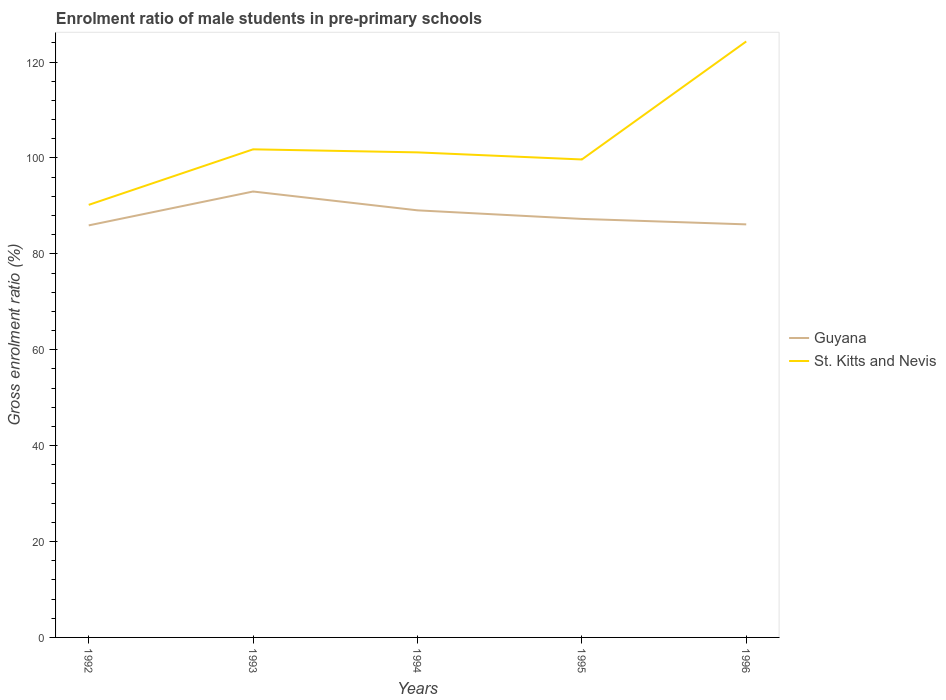Is the number of lines equal to the number of legend labels?
Your response must be concise. Yes. Across all years, what is the maximum enrolment ratio of male students in pre-primary schools in St. Kitts and Nevis?
Make the answer very short. 90.22. What is the total enrolment ratio of male students in pre-primary schools in St. Kitts and Nevis in the graph?
Your response must be concise. 0.64. What is the difference between the highest and the second highest enrolment ratio of male students in pre-primary schools in Guyana?
Your answer should be very brief. 7.06. Is the enrolment ratio of male students in pre-primary schools in St. Kitts and Nevis strictly greater than the enrolment ratio of male students in pre-primary schools in Guyana over the years?
Provide a succinct answer. No. How many lines are there?
Your answer should be very brief. 2. What is the difference between two consecutive major ticks on the Y-axis?
Keep it short and to the point. 20. Are the values on the major ticks of Y-axis written in scientific E-notation?
Provide a succinct answer. No. Does the graph contain grids?
Keep it short and to the point. No. Where does the legend appear in the graph?
Give a very brief answer. Center right. How many legend labels are there?
Your response must be concise. 2. How are the legend labels stacked?
Offer a terse response. Vertical. What is the title of the graph?
Offer a terse response. Enrolment ratio of male students in pre-primary schools. Does "St. Kitts and Nevis" appear as one of the legend labels in the graph?
Provide a short and direct response. Yes. What is the Gross enrolment ratio (%) of Guyana in 1992?
Your answer should be compact. 85.94. What is the Gross enrolment ratio (%) of St. Kitts and Nevis in 1992?
Make the answer very short. 90.22. What is the Gross enrolment ratio (%) in Guyana in 1993?
Offer a very short reply. 93. What is the Gross enrolment ratio (%) of St. Kitts and Nevis in 1993?
Keep it short and to the point. 101.8. What is the Gross enrolment ratio (%) of Guyana in 1994?
Give a very brief answer. 89.08. What is the Gross enrolment ratio (%) of St. Kitts and Nevis in 1994?
Your answer should be very brief. 101.17. What is the Gross enrolment ratio (%) in Guyana in 1995?
Your answer should be very brief. 87.29. What is the Gross enrolment ratio (%) in St. Kitts and Nevis in 1995?
Your answer should be compact. 99.69. What is the Gross enrolment ratio (%) of Guyana in 1996?
Keep it short and to the point. 86.15. What is the Gross enrolment ratio (%) in St. Kitts and Nevis in 1996?
Offer a terse response. 124.3. Across all years, what is the maximum Gross enrolment ratio (%) in Guyana?
Ensure brevity in your answer.  93. Across all years, what is the maximum Gross enrolment ratio (%) in St. Kitts and Nevis?
Your response must be concise. 124.3. Across all years, what is the minimum Gross enrolment ratio (%) in Guyana?
Ensure brevity in your answer.  85.94. Across all years, what is the minimum Gross enrolment ratio (%) in St. Kitts and Nevis?
Offer a terse response. 90.22. What is the total Gross enrolment ratio (%) of Guyana in the graph?
Your response must be concise. 441.46. What is the total Gross enrolment ratio (%) of St. Kitts and Nevis in the graph?
Keep it short and to the point. 517.18. What is the difference between the Gross enrolment ratio (%) of Guyana in 1992 and that in 1993?
Your answer should be very brief. -7.07. What is the difference between the Gross enrolment ratio (%) in St. Kitts and Nevis in 1992 and that in 1993?
Offer a terse response. -11.58. What is the difference between the Gross enrolment ratio (%) of Guyana in 1992 and that in 1994?
Your answer should be compact. -3.14. What is the difference between the Gross enrolment ratio (%) in St. Kitts and Nevis in 1992 and that in 1994?
Offer a terse response. -10.94. What is the difference between the Gross enrolment ratio (%) of Guyana in 1992 and that in 1995?
Your response must be concise. -1.35. What is the difference between the Gross enrolment ratio (%) of St. Kitts and Nevis in 1992 and that in 1995?
Offer a very short reply. -9.47. What is the difference between the Gross enrolment ratio (%) of Guyana in 1992 and that in 1996?
Give a very brief answer. -0.21. What is the difference between the Gross enrolment ratio (%) of St. Kitts and Nevis in 1992 and that in 1996?
Provide a succinct answer. -34.08. What is the difference between the Gross enrolment ratio (%) in Guyana in 1993 and that in 1994?
Your response must be concise. 3.93. What is the difference between the Gross enrolment ratio (%) of St. Kitts and Nevis in 1993 and that in 1994?
Provide a short and direct response. 0.64. What is the difference between the Gross enrolment ratio (%) of Guyana in 1993 and that in 1995?
Your response must be concise. 5.72. What is the difference between the Gross enrolment ratio (%) in St. Kitts and Nevis in 1993 and that in 1995?
Provide a succinct answer. 2.11. What is the difference between the Gross enrolment ratio (%) of Guyana in 1993 and that in 1996?
Ensure brevity in your answer.  6.86. What is the difference between the Gross enrolment ratio (%) of St. Kitts and Nevis in 1993 and that in 1996?
Keep it short and to the point. -22.5. What is the difference between the Gross enrolment ratio (%) of Guyana in 1994 and that in 1995?
Your answer should be compact. 1.79. What is the difference between the Gross enrolment ratio (%) in St. Kitts and Nevis in 1994 and that in 1995?
Provide a succinct answer. 1.48. What is the difference between the Gross enrolment ratio (%) of Guyana in 1994 and that in 1996?
Offer a terse response. 2.93. What is the difference between the Gross enrolment ratio (%) in St. Kitts and Nevis in 1994 and that in 1996?
Provide a succinct answer. -23.14. What is the difference between the Gross enrolment ratio (%) in Guyana in 1995 and that in 1996?
Provide a succinct answer. 1.14. What is the difference between the Gross enrolment ratio (%) in St. Kitts and Nevis in 1995 and that in 1996?
Ensure brevity in your answer.  -24.62. What is the difference between the Gross enrolment ratio (%) of Guyana in 1992 and the Gross enrolment ratio (%) of St. Kitts and Nevis in 1993?
Provide a succinct answer. -15.86. What is the difference between the Gross enrolment ratio (%) in Guyana in 1992 and the Gross enrolment ratio (%) in St. Kitts and Nevis in 1994?
Your response must be concise. -15.23. What is the difference between the Gross enrolment ratio (%) of Guyana in 1992 and the Gross enrolment ratio (%) of St. Kitts and Nevis in 1995?
Offer a very short reply. -13.75. What is the difference between the Gross enrolment ratio (%) in Guyana in 1992 and the Gross enrolment ratio (%) in St. Kitts and Nevis in 1996?
Your answer should be compact. -38.36. What is the difference between the Gross enrolment ratio (%) of Guyana in 1993 and the Gross enrolment ratio (%) of St. Kitts and Nevis in 1994?
Offer a terse response. -8.16. What is the difference between the Gross enrolment ratio (%) in Guyana in 1993 and the Gross enrolment ratio (%) in St. Kitts and Nevis in 1995?
Your response must be concise. -6.68. What is the difference between the Gross enrolment ratio (%) in Guyana in 1993 and the Gross enrolment ratio (%) in St. Kitts and Nevis in 1996?
Ensure brevity in your answer.  -31.3. What is the difference between the Gross enrolment ratio (%) in Guyana in 1994 and the Gross enrolment ratio (%) in St. Kitts and Nevis in 1995?
Keep it short and to the point. -10.61. What is the difference between the Gross enrolment ratio (%) in Guyana in 1994 and the Gross enrolment ratio (%) in St. Kitts and Nevis in 1996?
Keep it short and to the point. -35.22. What is the difference between the Gross enrolment ratio (%) of Guyana in 1995 and the Gross enrolment ratio (%) of St. Kitts and Nevis in 1996?
Keep it short and to the point. -37.01. What is the average Gross enrolment ratio (%) of Guyana per year?
Offer a terse response. 88.29. What is the average Gross enrolment ratio (%) of St. Kitts and Nevis per year?
Your answer should be very brief. 103.44. In the year 1992, what is the difference between the Gross enrolment ratio (%) in Guyana and Gross enrolment ratio (%) in St. Kitts and Nevis?
Your answer should be very brief. -4.28. In the year 1993, what is the difference between the Gross enrolment ratio (%) of Guyana and Gross enrolment ratio (%) of St. Kitts and Nevis?
Provide a short and direct response. -8.8. In the year 1994, what is the difference between the Gross enrolment ratio (%) of Guyana and Gross enrolment ratio (%) of St. Kitts and Nevis?
Provide a short and direct response. -12.09. In the year 1995, what is the difference between the Gross enrolment ratio (%) of Guyana and Gross enrolment ratio (%) of St. Kitts and Nevis?
Ensure brevity in your answer.  -12.4. In the year 1996, what is the difference between the Gross enrolment ratio (%) of Guyana and Gross enrolment ratio (%) of St. Kitts and Nevis?
Your answer should be compact. -38.15. What is the ratio of the Gross enrolment ratio (%) of Guyana in 1992 to that in 1993?
Provide a succinct answer. 0.92. What is the ratio of the Gross enrolment ratio (%) in St. Kitts and Nevis in 1992 to that in 1993?
Offer a terse response. 0.89. What is the ratio of the Gross enrolment ratio (%) of Guyana in 1992 to that in 1994?
Provide a succinct answer. 0.96. What is the ratio of the Gross enrolment ratio (%) in St. Kitts and Nevis in 1992 to that in 1994?
Provide a short and direct response. 0.89. What is the ratio of the Gross enrolment ratio (%) of Guyana in 1992 to that in 1995?
Give a very brief answer. 0.98. What is the ratio of the Gross enrolment ratio (%) of St. Kitts and Nevis in 1992 to that in 1995?
Provide a short and direct response. 0.91. What is the ratio of the Gross enrolment ratio (%) in Guyana in 1992 to that in 1996?
Give a very brief answer. 1. What is the ratio of the Gross enrolment ratio (%) of St. Kitts and Nevis in 1992 to that in 1996?
Keep it short and to the point. 0.73. What is the ratio of the Gross enrolment ratio (%) of Guyana in 1993 to that in 1994?
Your response must be concise. 1.04. What is the ratio of the Gross enrolment ratio (%) in Guyana in 1993 to that in 1995?
Give a very brief answer. 1.07. What is the ratio of the Gross enrolment ratio (%) of St. Kitts and Nevis in 1993 to that in 1995?
Provide a short and direct response. 1.02. What is the ratio of the Gross enrolment ratio (%) in Guyana in 1993 to that in 1996?
Your response must be concise. 1.08. What is the ratio of the Gross enrolment ratio (%) in St. Kitts and Nevis in 1993 to that in 1996?
Offer a terse response. 0.82. What is the ratio of the Gross enrolment ratio (%) in Guyana in 1994 to that in 1995?
Provide a succinct answer. 1.02. What is the ratio of the Gross enrolment ratio (%) of St. Kitts and Nevis in 1994 to that in 1995?
Offer a terse response. 1.01. What is the ratio of the Gross enrolment ratio (%) in Guyana in 1994 to that in 1996?
Your answer should be very brief. 1.03. What is the ratio of the Gross enrolment ratio (%) of St. Kitts and Nevis in 1994 to that in 1996?
Offer a terse response. 0.81. What is the ratio of the Gross enrolment ratio (%) of Guyana in 1995 to that in 1996?
Ensure brevity in your answer.  1.01. What is the ratio of the Gross enrolment ratio (%) in St. Kitts and Nevis in 1995 to that in 1996?
Provide a succinct answer. 0.8. What is the difference between the highest and the second highest Gross enrolment ratio (%) in Guyana?
Offer a terse response. 3.93. What is the difference between the highest and the second highest Gross enrolment ratio (%) in St. Kitts and Nevis?
Your answer should be very brief. 22.5. What is the difference between the highest and the lowest Gross enrolment ratio (%) in Guyana?
Give a very brief answer. 7.07. What is the difference between the highest and the lowest Gross enrolment ratio (%) of St. Kitts and Nevis?
Keep it short and to the point. 34.08. 